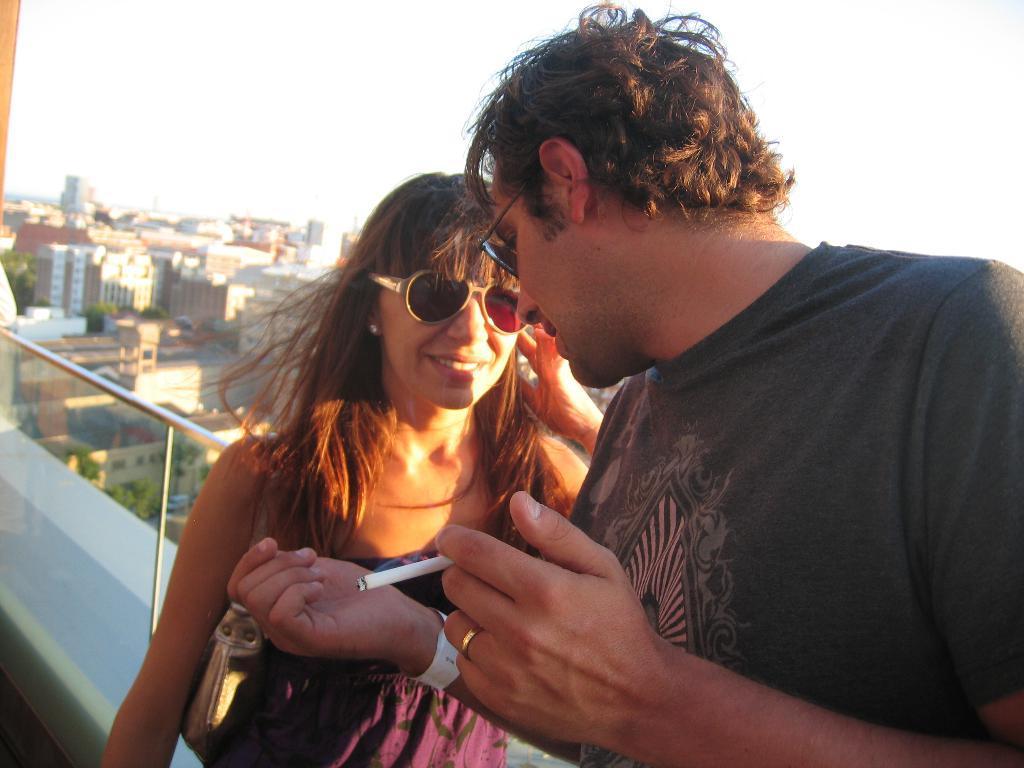In one or two sentences, can you explain what this image depicts? In the picture I can see a man and a woman are standing. The man is holding a cigarette in the hand. In the background I can see buildings and the sky. I can also trees. The background of the image is blurred. 